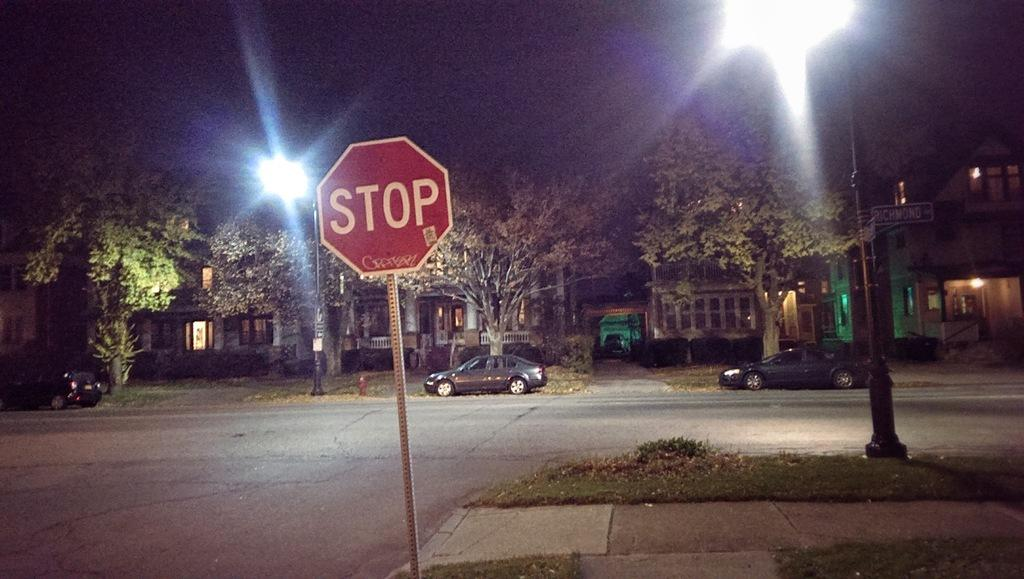<image>
Summarize the visual content of the image. a stop sign that is outside with many lights 